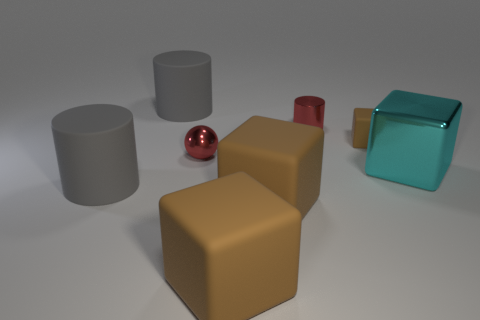Is the metallic sphere the same color as the metallic cylinder?
Your answer should be very brief. Yes. Is the shape of the gray object behind the large metallic object the same as  the large cyan metal object?
Your answer should be very brief. No. How many red objects have the same size as the cyan thing?
Offer a terse response. 0. There is a tiny metallic thing that is the same color as the shiny sphere; what shape is it?
Offer a terse response. Cylinder. There is a gray matte thing behind the tiny red cylinder; is there a tiny sphere in front of it?
Provide a succinct answer. Yes. What number of objects are either gray cylinders in front of the tiny brown matte cube or tiny shiny cylinders?
Your answer should be very brief. 2. What number of cyan objects are there?
Provide a succinct answer. 1. What is the shape of the red thing that is the same material as the tiny sphere?
Provide a short and direct response. Cylinder. There is a brown thing that is behind the large gray matte thing in front of the big metal block; what is its size?
Give a very brief answer. Small. How many things are cylinders that are behind the cyan metal block or metal things that are on the left side of the big cyan cube?
Offer a terse response. 3. 